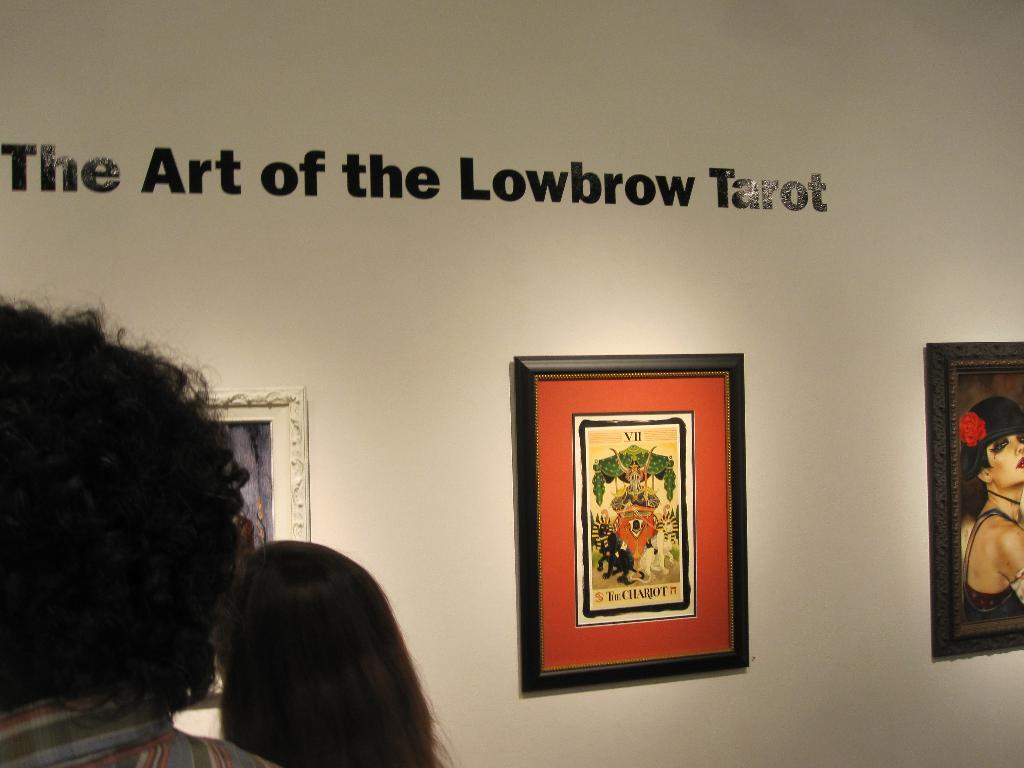What can be seen hanging on the wall in the image? There are frames on the wall in the image. Where are the people located in the image? The people are on the left side of the image. What is written on the wall in the image? There is something written on the wall with black letters in the top of the image. How many rabbits are hopping around in the image? There are no rabbits present in the image. What type of scarecrow can be seen in the image? There is no scarecrow present in the image. 